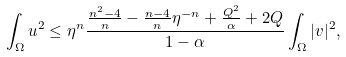Convert formula to latex. <formula><loc_0><loc_0><loc_500><loc_500>\int _ { \Omega } u ^ { 2 } \leq \eta ^ { n } \frac { \frac { n ^ { 2 } - 4 } { n } - \frac { n - 4 } { n } \eta ^ { - n } + \frac { Q ^ { 2 } } { \alpha } + 2 Q } { 1 - \alpha } \int _ { \Omega } | v | ^ { 2 } ,</formula> 